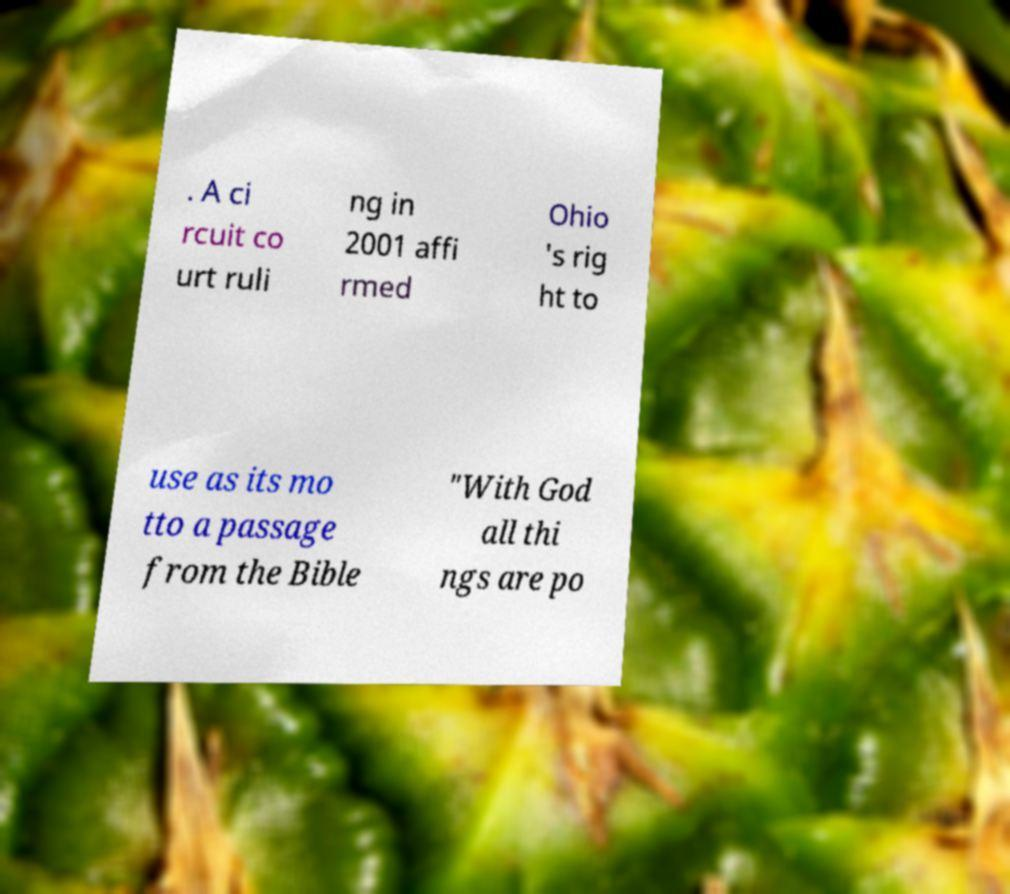There's text embedded in this image that I need extracted. Can you transcribe it verbatim? . A ci rcuit co urt ruli ng in 2001 affi rmed Ohio 's rig ht to use as its mo tto a passage from the Bible "With God all thi ngs are po 